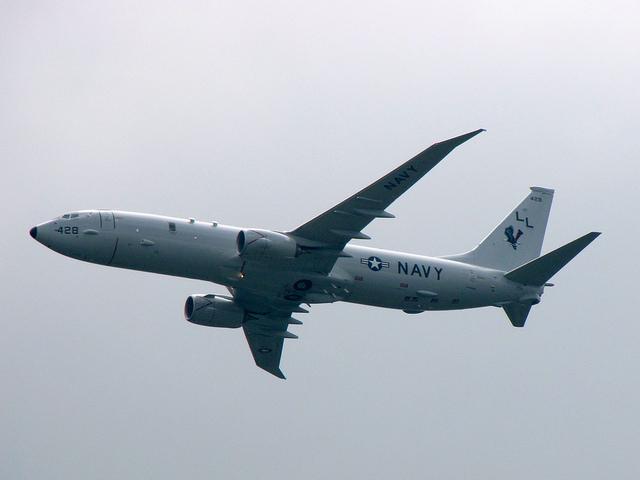How many engines are pictured?
Give a very brief answer. 2. 